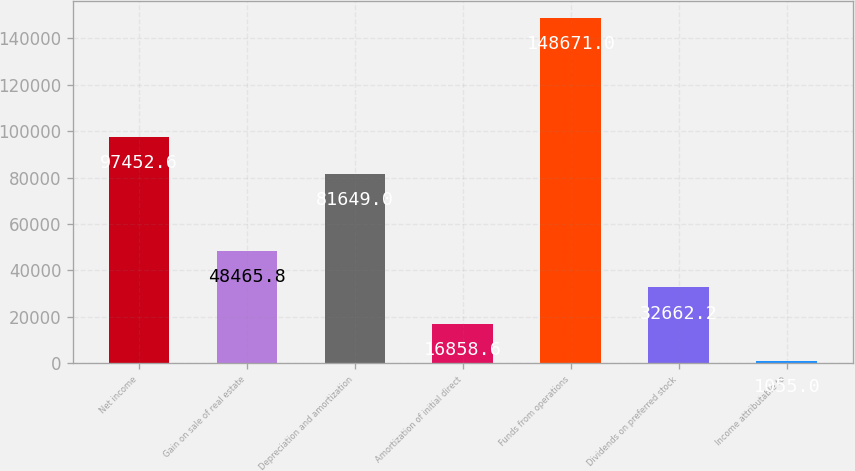<chart> <loc_0><loc_0><loc_500><loc_500><bar_chart><fcel>Net income<fcel>Gain on sale of real estate<fcel>Depreciation and amortization<fcel>Amortization of initial direct<fcel>Funds from operations<fcel>Dividends on preferred stock<fcel>Income attributable to<nl><fcel>97452.6<fcel>48465.8<fcel>81649<fcel>16858.6<fcel>148671<fcel>32662.2<fcel>1055<nl></chart> 